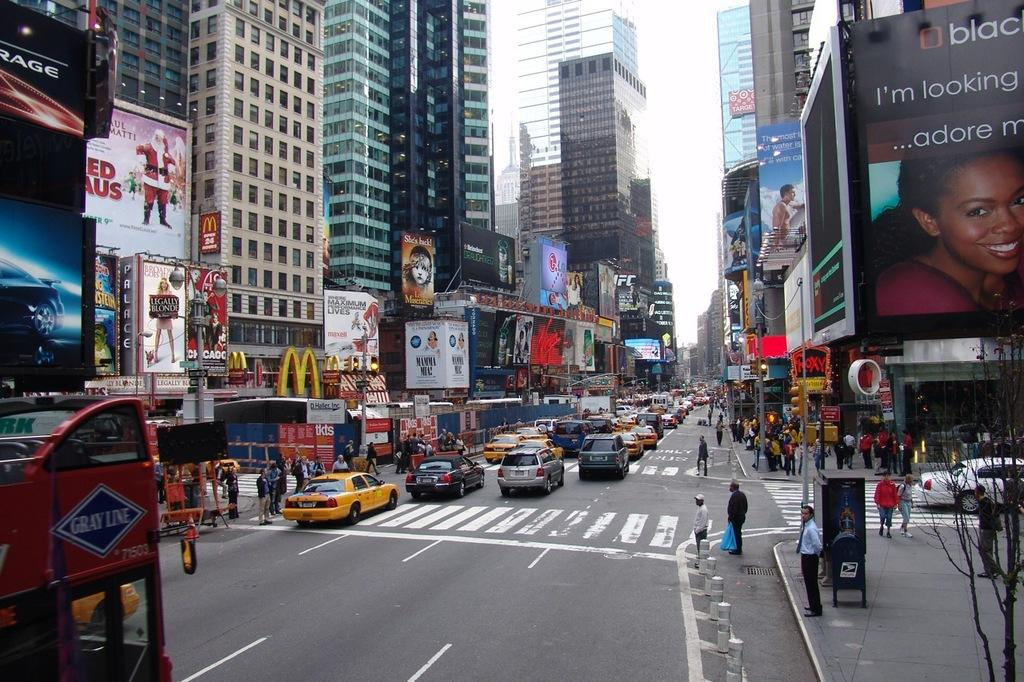<image>
Render a clear and concise summary of the photo. A Mc Donalds ad can be seen on this busy street. 